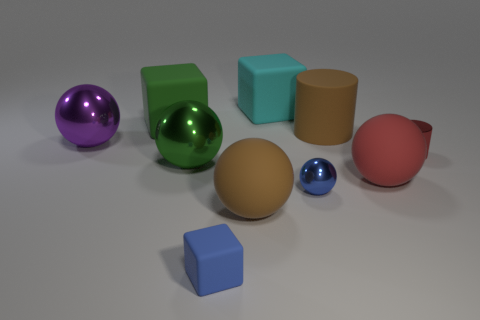Subtract all red spheres. How many spheres are left? 4 Subtract all green balls. How many balls are left? 4 Subtract all yellow spheres. Subtract all blue cylinders. How many spheres are left? 5 Subtract all cylinders. How many objects are left? 8 Subtract 0 yellow cylinders. How many objects are left? 10 Subtract all red shiny spheres. Subtract all big green rubber cubes. How many objects are left? 9 Add 9 big brown rubber balls. How many big brown rubber balls are left? 10 Add 9 large purple matte balls. How many large purple matte balls exist? 9 